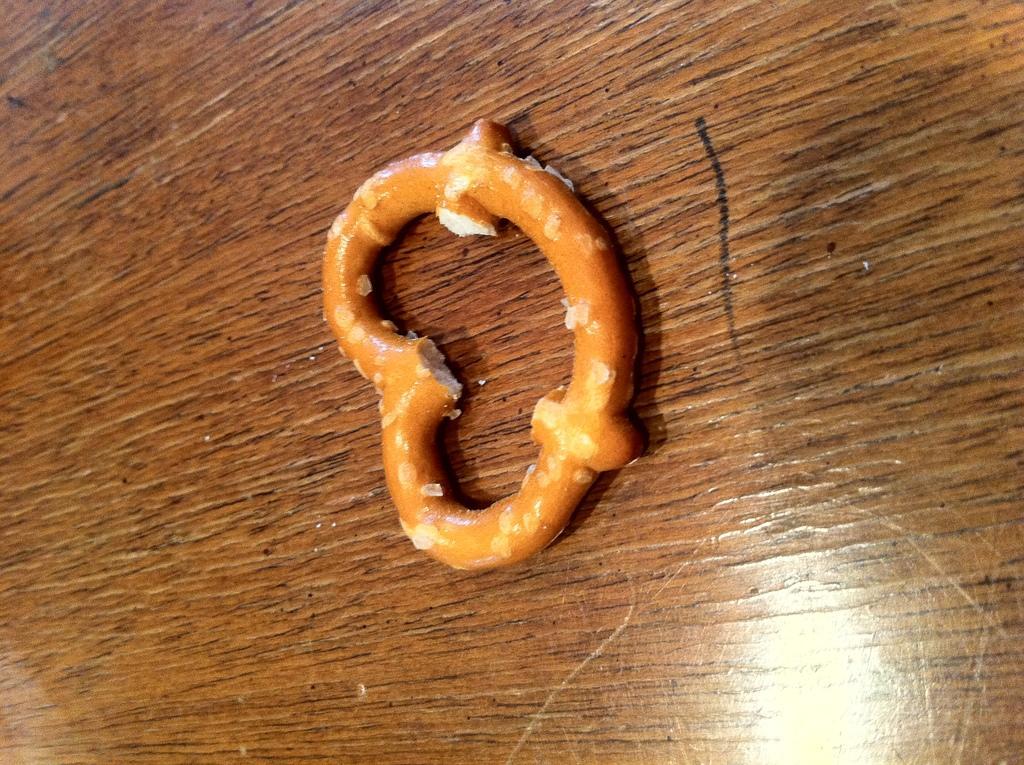Could you give a brief overview of what you see in this image? On this wooden surface we can see a food. 